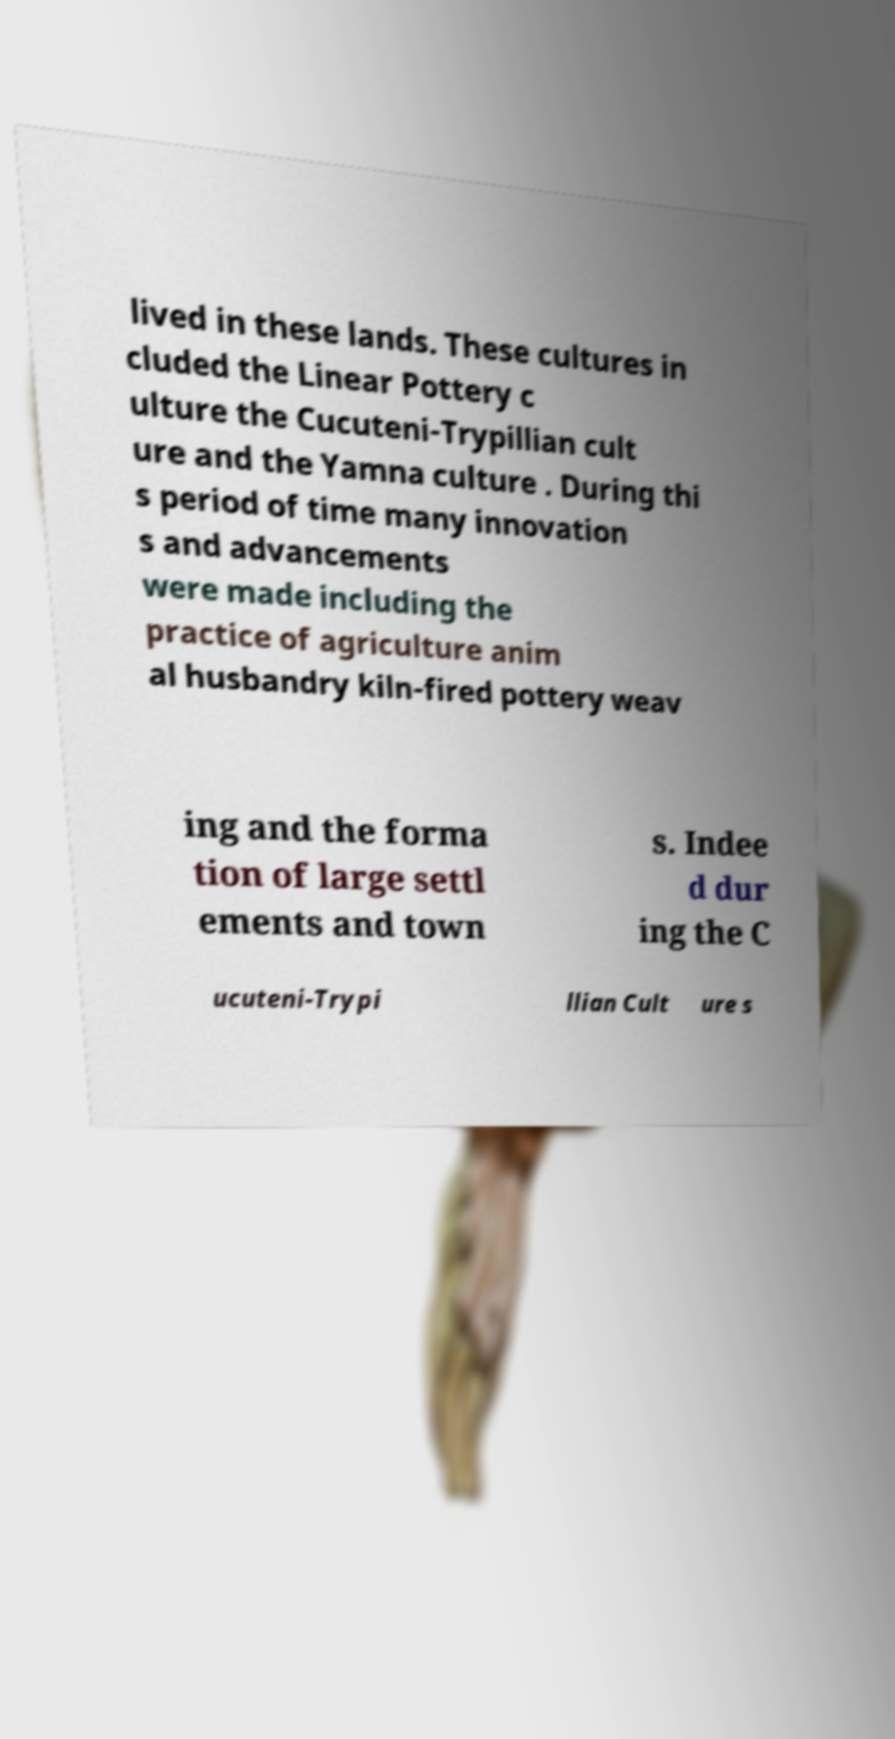What messages or text are displayed in this image? I need them in a readable, typed format. lived in these lands. These cultures in cluded the Linear Pottery c ulture the Cucuteni-Trypillian cult ure and the Yamna culture . During thi s period of time many innovation s and advancements were made including the practice of agriculture anim al husbandry kiln-fired pottery weav ing and the forma tion of large settl ements and town s. Indee d dur ing the C ucuteni-Trypi llian Cult ure s 